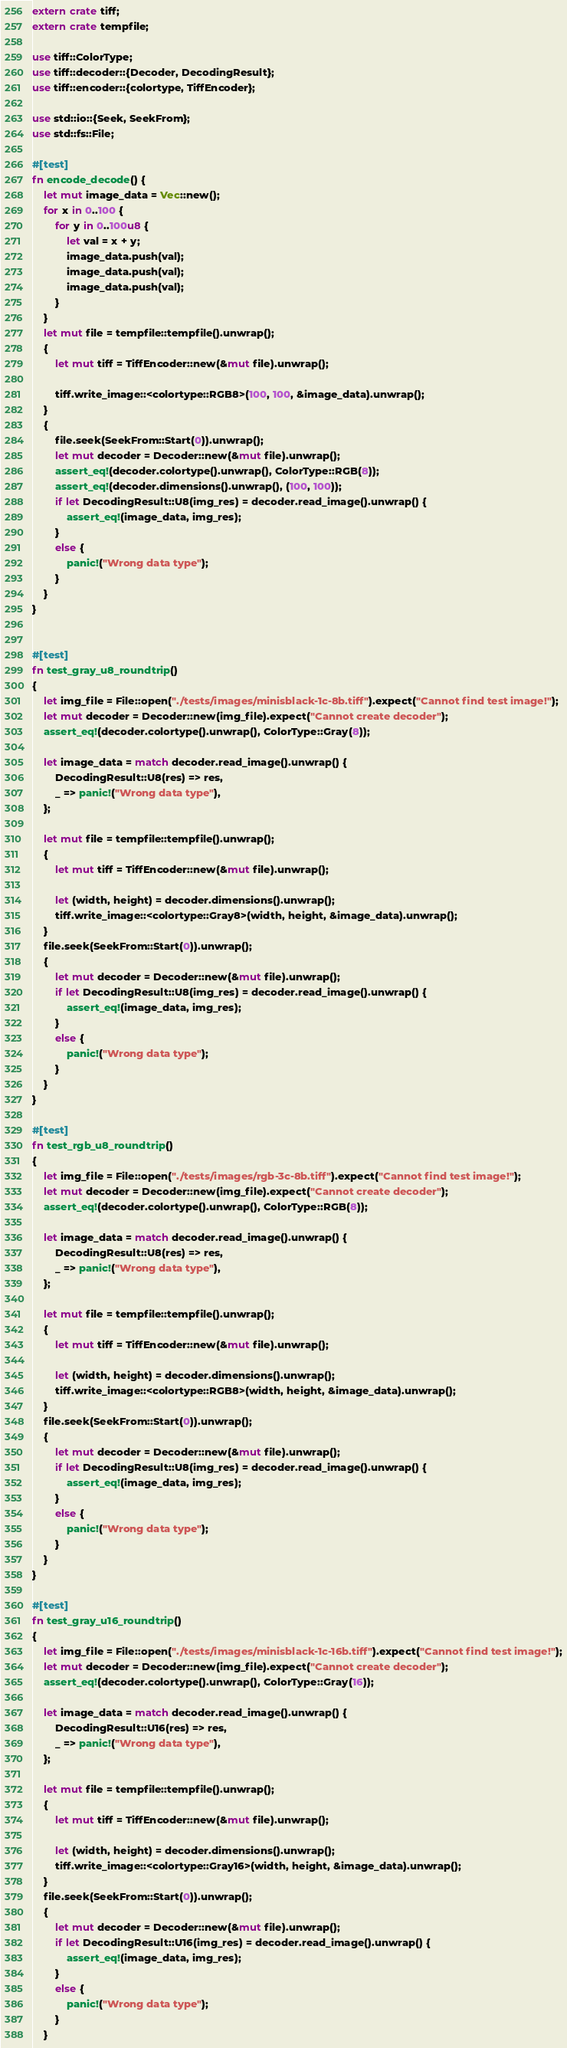Convert code to text. <code><loc_0><loc_0><loc_500><loc_500><_Rust_>extern crate tiff;
extern crate tempfile;

use tiff::ColorType;
use tiff::decoder::{Decoder, DecodingResult};
use tiff::encoder::{colortype, TiffEncoder};

use std::io::{Seek, SeekFrom};
use std::fs::File;

#[test]
fn encode_decode() {
    let mut image_data = Vec::new();
    for x in 0..100 {
        for y in 0..100u8 {
            let val = x + y;
            image_data.push(val);
            image_data.push(val);
            image_data.push(val);
        }
    }
    let mut file = tempfile::tempfile().unwrap();
    {
        let mut tiff = TiffEncoder::new(&mut file).unwrap();

        tiff.write_image::<colortype::RGB8>(100, 100, &image_data).unwrap();
    }
    {
        file.seek(SeekFrom::Start(0)).unwrap();
        let mut decoder = Decoder::new(&mut file).unwrap();
        assert_eq!(decoder.colortype().unwrap(), ColorType::RGB(8));
        assert_eq!(decoder.dimensions().unwrap(), (100, 100));
        if let DecodingResult::U8(img_res) = decoder.read_image().unwrap() {
            assert_eq!(image_data, img_res);
        }
        else {
            panic!("Wrong data type");
        }
    }
}


#[test]
fn test_gray_u8_roundtrip()
{
    let img_file = File::open("./tests/images/minisblack-1c-8b.tiff").expect("Cannot find test image!");
    let mut decoder = Decoder::new(img_file).expect("Cannot create decoder");
    assert_eq!(decoder.colortype().unwrap(), ColorType::Gray(8));

    let image_data = match decoder.read_image().unwrap() {
        DecodingResult::U8(res) => res,
        _ => panic!("Wrong data type"),
    };

    let mut file = tempfile::tempfile().unwrap();
    {
        let mut tiff = TiffEncoder::new(&mut file).unwrap();
    
        let (width, height) = decoder.dimensions().unwrap();
        tiff.write_image::<colortype::Gray8>(width, height, &image_data).unwrap();
    }
    file.seek(SeekFrom::Start(0)).unwrap();
    {
        let mut decoder = Decoder::new(&mut file).unwrap();
        if let DecodingResult::U8(img_res) = decoder.read_image().unwrap() {
            assert_eq!(image_data, img_res);
        }
        else {
            panic!("Wrong data type");
        }
    }
}

#[test]
fn test_rgb_u8_roundtrip()
{
    let img_file = File::open("./tests/images/rgb-3c-8b.tiff").expect("Cannot find test image!");
    let mut decoder = Decoder::new(img_file).expect("Cannot create decoder");
    assert_eq!(decoder.colortype().unwrap(), ColorType::RGB(8));

    let image_data = match decoder.read_image().unwrap() {
        DecodingResult::U8(res) => res,
        _ => panic!("Wrong data type"),
    };

    let mut file = tempfile::tempfile().unwrap();
    {
        let mut tiff = TiffEncoder::new(&mut file).unwrap();
    
        let (width, height) = decoder.dimensions().unwrap();
        tiff.write_image::<colortype::RGB8>(width, height, &image_data).unwrap();
    }
    file.seek(SeekFrom::Start(0)).unwrap();
    {
        let mut decoder = Decoder::new(&mut file).unwrap();
        if let DecodingResult::U8(img_res) = decoder.read_image().unwrap() {
            assert_eq!(image_data, img_res);
        }
        else {
            panic!("Wrong data type");
        }
    }
}

#[test]
fn test_gray_u16_roundtrip()
{
    let img_file = File::open("./tests/images/minisblack-1c-16b.tiff").expect("Cannot find test image!");
    let mut decoder = Decoder::new(img_file).expect("Cannot create decoder");
    assert_eq!(decoder.colortype().unwrap(), ColorType::Gray(16));

    let image_data = match decoder.read_image().unwrap() {
        DecodingResult::U16(res) => res,
        _ => panic!("Wrong data type"),
    };

    let mut file = tempfile::tempfile().unwrap();
    {
        let mut tiff = TiffEncoder::new(&mut file).unwrap();
    
        let (width, height) = decoder.dimensions().unwrap();
        tiff.write_image::<colortype::Gray16>(width, height, &image_data).unwrap();
    }
    file.seek(SeekFrom::Start(0)).unwrap();
    {
        let mut decoder = Decoder::new(&mut file).unwrap();
        if let DecodingResult::U16(img_res) = decoder.read_image().unwrap() {
            assert_eq!(image_data, img_res);
        }
        else {
            panic!("Wrong data type");
        }
    }</code> 